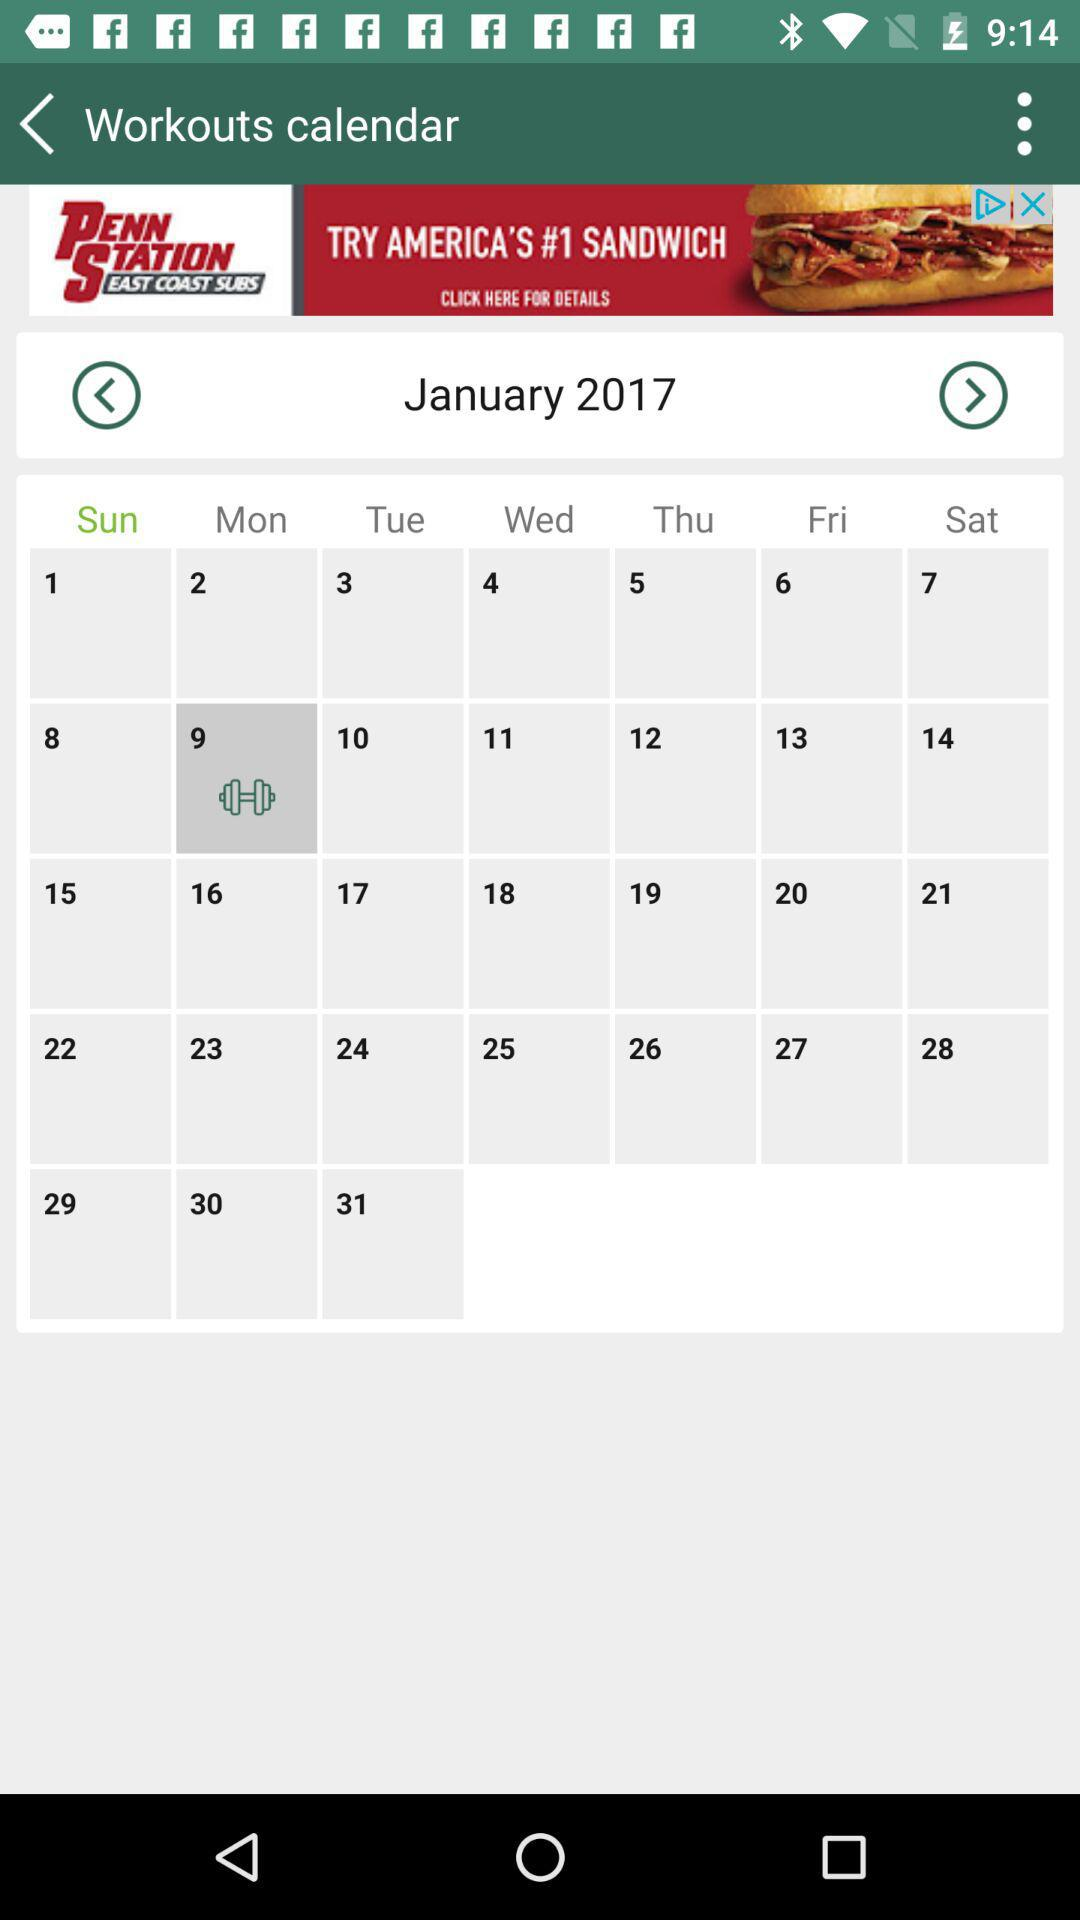How many workouts are there in the month of January?
Answer the question using a single word or phrase. 31 